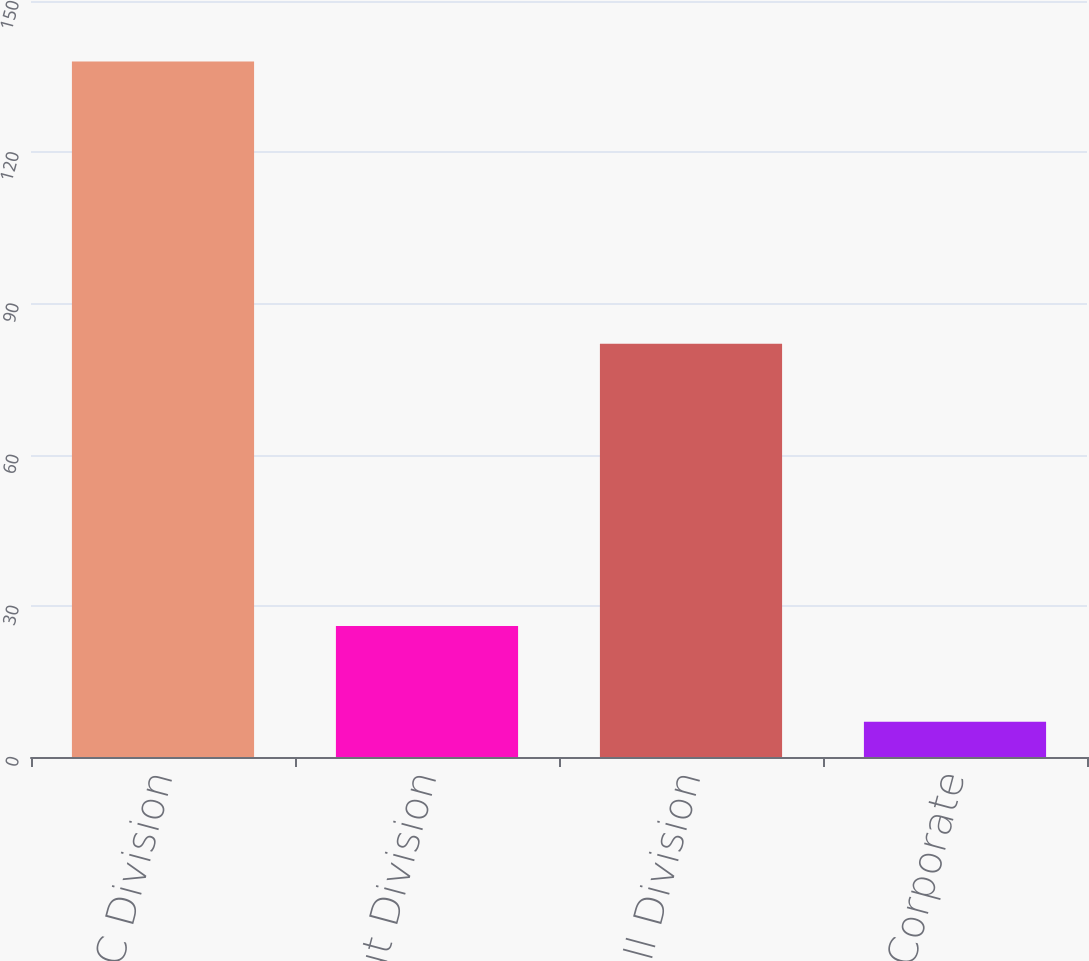Convert chart. <chart><loc_0><loc_0><loc_500><loc_500><bar_chart><fcel>KFC Division<fcel>Pizza Hut Division<fcel>Taco Bell Division<fcel>Corporate<nl><fcel>138<fcel>26<fcel>82<fcel>7<nl></chart> 